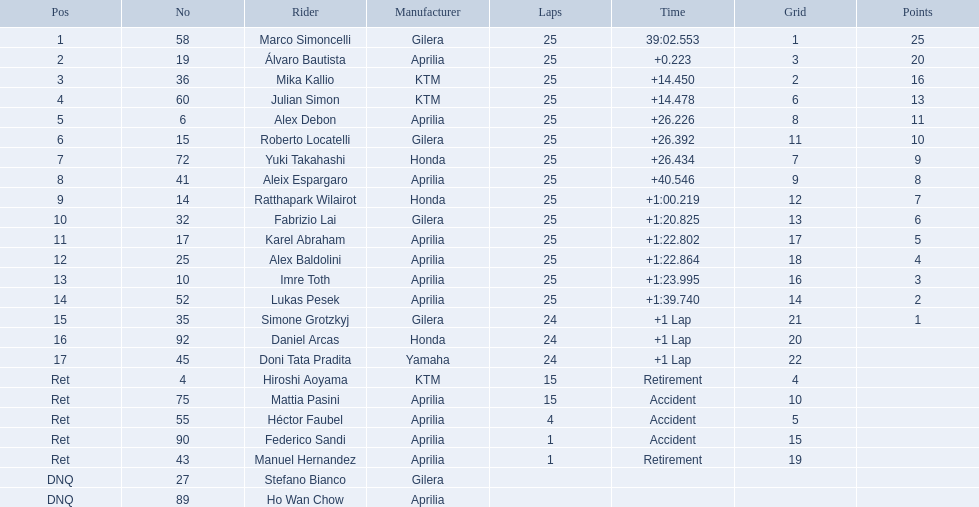How many circuits did hiroshi aoyama complete? 15. How many circuits did marco simoncelli complete? 25. Write the full table. {'header': ['Pos', 'No', 'Rider', 'Manufacturer', 'Laps', 'Time', 'Grid', 'Points'], 'rows': [['1', '58', 'Marco Simoncelli', 'Gilera', '25', '39:02.553', '1', '25'], ['2', '19', 'Álvaro Bautista', 'Aprilia', '25', '+0.223', '3', '20'], ['3', '36', 'Mika Kallio', 'KTM', '25', '+14.450', '2', '16'], ['4', '60', 'Julian Simon', 'KTM', '25', '+14.478', '6', '13'], ['5', '6', 'Alex Debon', 'Aprilia', '25', '+26.226', '8', '11'], ['6', '15', 'Roberto Locatelli', 'Gilera', '25', '+26.392', '11', '10'], ['7', '72', 'Yuki Takahashi', 'Honda', '25', '+26.434', '7', '9'], ['8', '41', 'Aleix Espargaro', 'Aprilia', '25', '+40.546', '9', '8'], ['9', '14', 'Ratthapark Wilairot', 'Honda', '25', '+1:00.219', '12', '7'], ['10', '32', 'Fabrizio Lai', 'Gilera', '25', '+1:20.825', '13', '6'], ['11', '17', 'Karel Abraham', 'Aprilia', '25', '+1:22.802', '17', '5'], ['12', '25', 'Alex Baldolini', 'Aprilia', '25', '+1:22.864', '18', '4'], ['13', '10', 'Imre Toth', 'Aprilia', '25', '+1:23.995', '16', '3'], ['14', '52', 'Lukas Pesek', 'Aprilia', '25', '+1:39.740', '14', '2'], ['15', '35', 'Simone Grotzkyj', 'Gilera', '24', '+1 Lap', '21', '1'], ['16', '92', 'Daniel Arcas', 'Honda', '24', '+1 Lap', '20', ''], ['17', '45', 'Doni Tata Pradita', 'Yamaha', '24', '+1 Lap', '22', ''], ['Ret', '4', 'Hiroshi Aoyama', 'KTM', '15', 'Retirement', '4', ''], ['Ret', '75', 'Mattia Pasini', 'Aprilia', '15', 'Accident', '10', ''], ['Ret', '55', 'Héctor Faubel', 'Aprilia', '4', 'Accident', '5', ''], ['Ret', '90', 'Federico Sandi', 'Aprilia', '1', 'Accident', '15', ''], ['Ret', '43', 'Manuel Hernandez', 'Aprilia', '1', 'Retirement', '19', ''], ['DNQ', '27', 'Stefano Bianco', 'Gilera', '', '', '', ''], ['DNQ', '89', 'Ho Wan Chow', 'Aprilia', '', '', '', '']]} Who completed more circuits between hiroshi aoyama and marco simoncelli? Marco Simoncelli. 